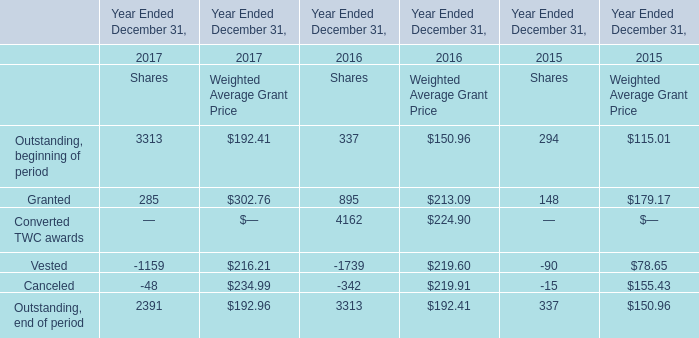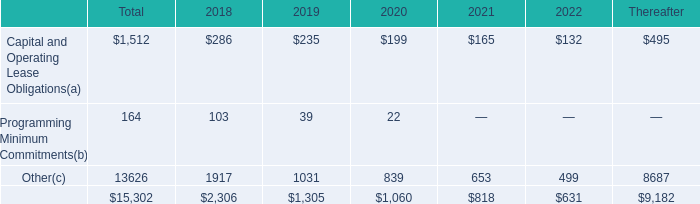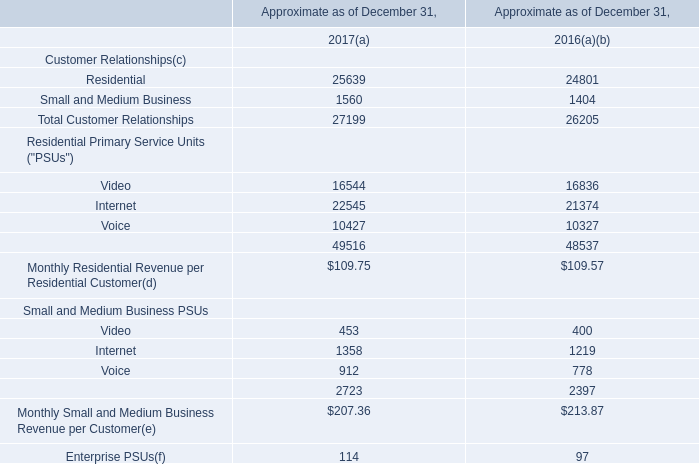Which year is Outstanding, beginning of period at Weighted Average Grant Price the lowest? 
Answer: 2015. 